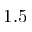<formula> <loc_0><loc_0><loc_500><loc_500>1 . 5</formula> 